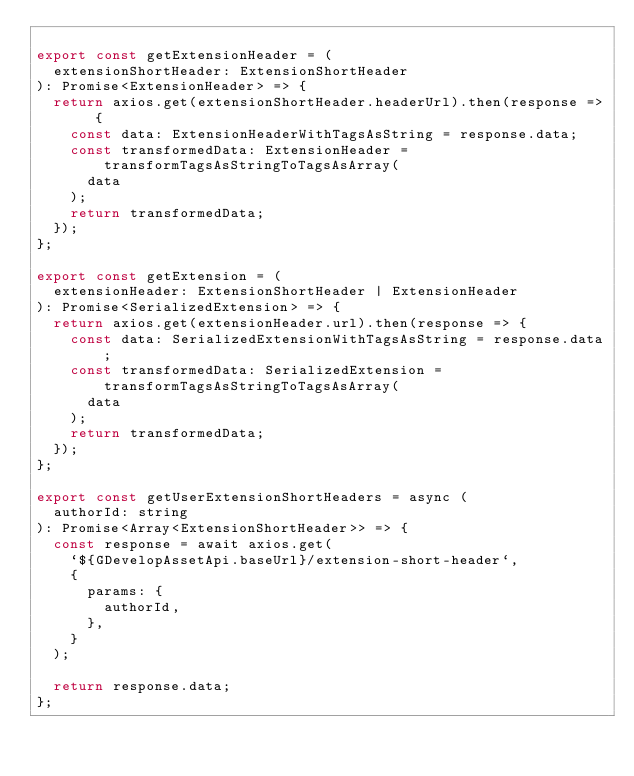<code> <loc_0><loc_0><loc_500><loc_500><_JavaScript_>
export const getExtensionHeader = (
  extensionShortHeader: ExtensionShortHeader
): Promise<ExtensionHeader> => {
  return axios.get(extensionShortHeader.headerUrl).then(response => {
    const data: ExtensionHeaderWithTagsAsString = response.data;
    const transformedData: ExtensionHeader = transformTagsAsStringToTagsAsArray(
      data
    );
    return transformedData;
  });
};

export const getExtension = (
  extensionHeader: ExtensionShortHeader | ExtensionHeader
): Promise<SerializedExtension> => {
  return axios.get(extensionHeader.url).then(response => {
    const data: SerializedExtensionWithTagsAsString = response.data;
    const transformedData: SerializedExtension = transformTagsAsStringToTagsAsArray(
      data
    );
    return transformedData;
  });
};

export const getUserExtensionShortHeaders = async (
  authorId: string
): Promise<Array<ExtensionShortHeader>> => {
  const response = await axios.get(
    `${GDevelopAssetApi.baseUrl}/extension-short-header`,
    {
      params: {
        authorId,
      },
    }
  );

  return response.data;
};
</code> 